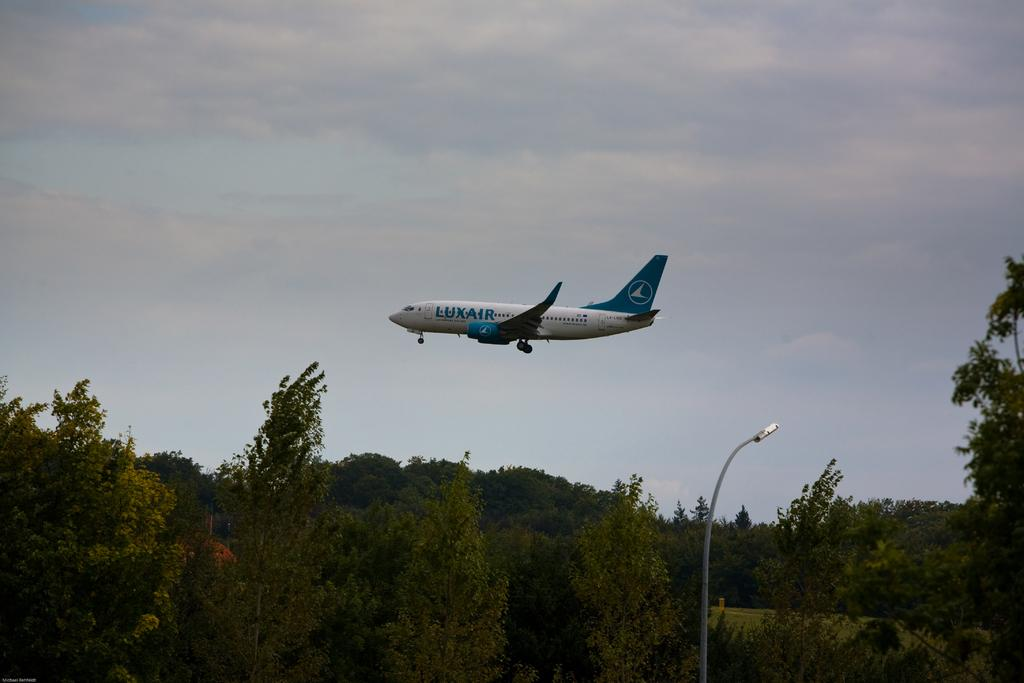<image>
Relay a brief, clear account of the picture shown. A white and LuxAir airplane makes its final descent to the runway above a tick forest of trees 